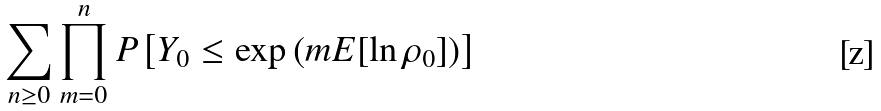<formula> <loc_0><loc_0><loc_500><loc_500>\sum _ { n \geq 0 } \prod _ { m = 0 } ^ { n } P \left [ Y _ { 0 } \leq \exp \left ( m E [ \ln \rho _ { 0 } ] \right ) \right ]</formula> 